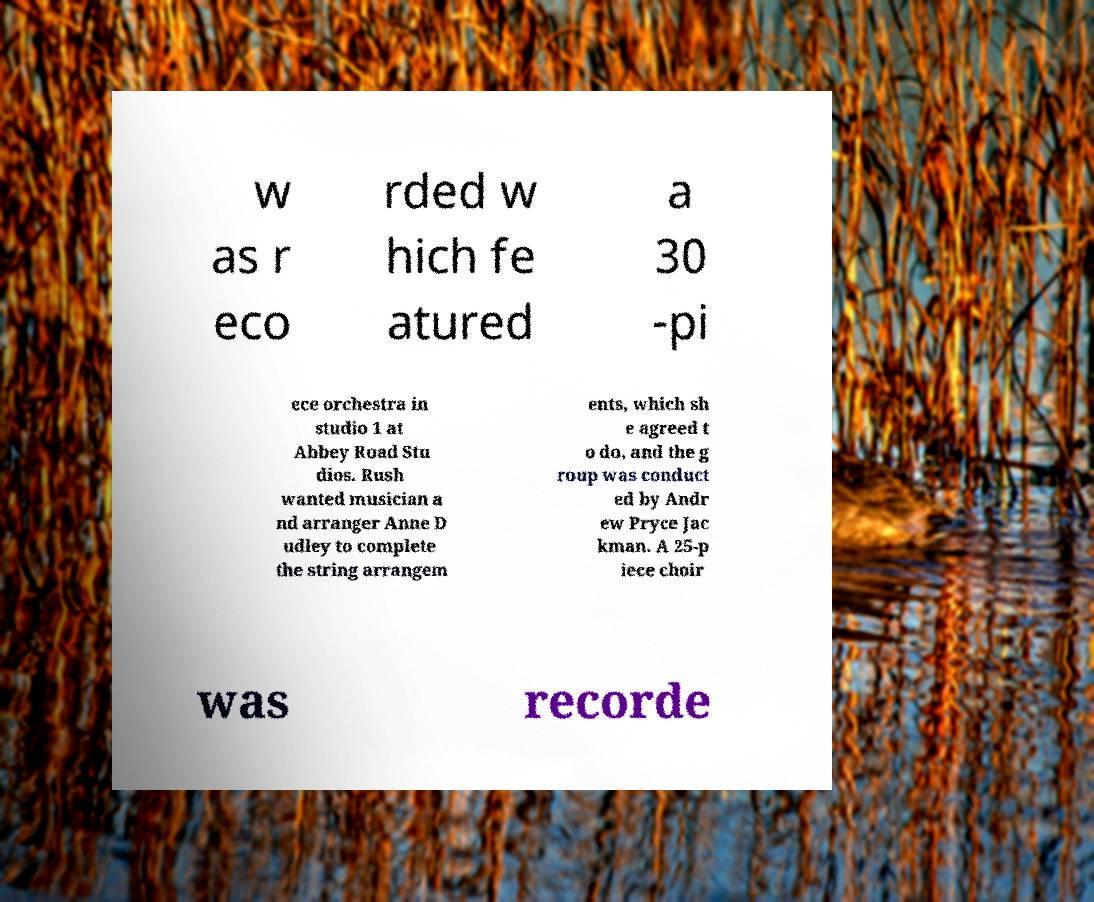Can you read and provide the text displayed in the image?This photo seems to have some interesting text. Can you extract and type it out for me? w as r eco rded w hich fe atured a 30 -pi ece orchestra in studio 1 at Abbey Road Stu dios. Rush wanted musician a nd arranger Anne D udley to complete the string arrangem ents, which sh e agreed t o do, and the g roup was conduct ed by Andr ew Pryce Jac kman. A 25-p iece choir was recorde 